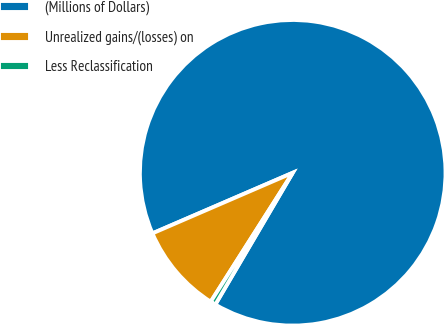Convert chart to OTSL. <chart><loc_0><loc_0><loc_500><loc_500><pie_chart><fcel>(Millions of Dollars)<fcel>Unrealized gains/(losses) on<fcel>Less Reclassification<nl><fcel>89.95%<fcel>9.5%<fcel>0.56%<nl></chart> 